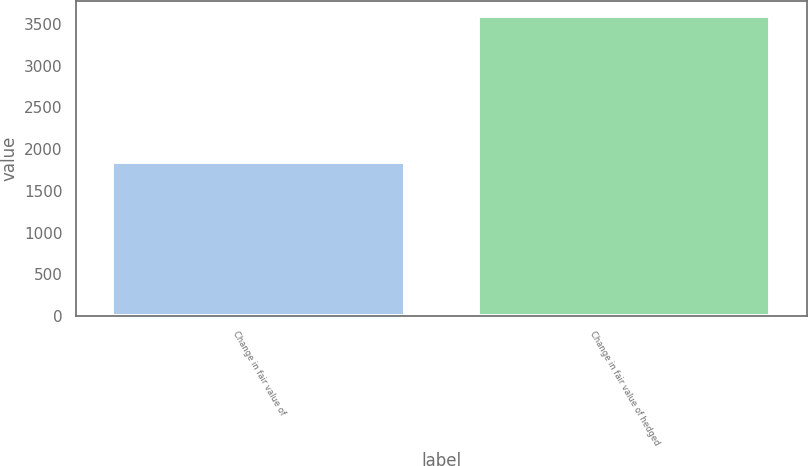<chart> <loc_0><loc_0><loc_500><loc_500><bar_chart><fcel>Change in fair value of<fcel>Change in fair value of hedged<nl><fcel>1847<fcel>3594.2<nl></chart> 